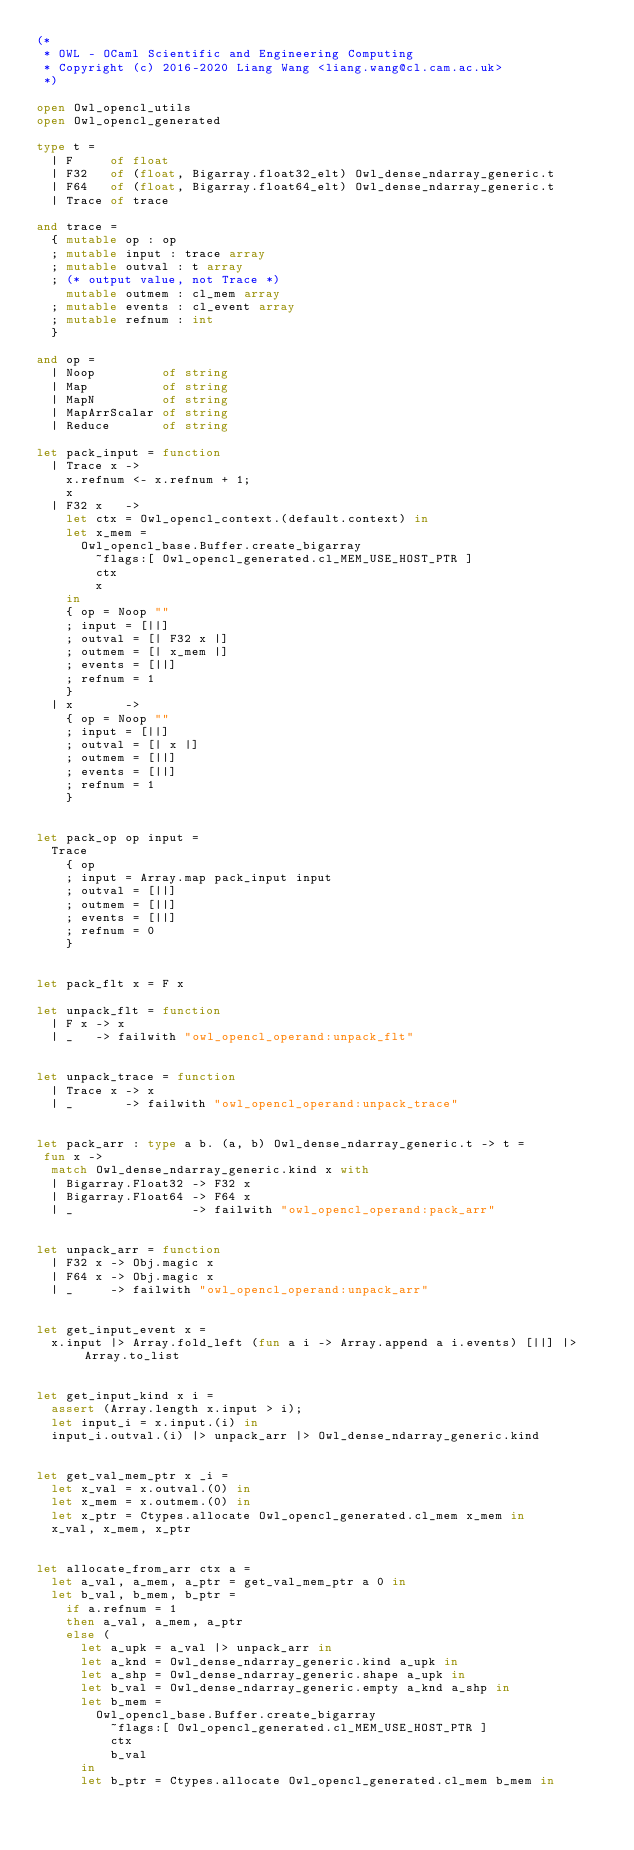<code> <loc_0><loc_0><loc_500><loc_500><_OCaml_>(*
 * OWL - OCaml Scientific and Engineering Computing
 * Copyright (c) 2016-2020 Liang Wang <liang.wang@cl.cam.ac.uk>
 *)

open Owl_opencl_utils
open Owl_opencl_generated

type t =
  | F     of float
  | F32   of (float, Bigarray.float32_elt) Owl_dense_ndarray_generic.t
  | F64   of (float, Bigarray.float64_elt) Owl_dense_ndarray_generic.t
  | Trace of trace

and trace =
  { mutable op : op
  ; mutable input : trace array
  ; mutable outval : t array
  ; (* output value, not Trace *)
    mutable outmem : cl_mem array
  ; mutable events : cl_event array
  ; mutable refnum : int
  }

and op =
  | Noop         of string
  | Map          of string
  | MapN         of string
  | MapArrScalar of string
  | Reduce       of string

let pack_input = function
  | Trace x ->
    x.refnum <- x.refnum + 1;
    x
  | F32 x   ->
    let ctx = Owl_opencl_context.(default.context) in
    let x_mem =
      Owl_opencl_base.Buffer.create_bigarray
        ~flags:[ Owl_opencl_generated.cl_MEM_USE_HOST_PTR ]
        ctx
        x
    in
    { op = Noop ""
    ; input = [||]
    ; outval = [| F32 x |]
    ; outmem = [| x_mem |]
    ; events = [||]
    ; refnum = 1
    }
  | x       ->
    { op = Noop ""
    ; input = [||]
    ; outval = [| x |]
    ; outmem = [||]
    ; events = [||]
    ; refnum = 1
    }


let pack_op op input =
  Trace
    { op
    ; input = Array.map pack_input input
    ; outval = [||]
    ; outmem = [||]
    ; events = [||]
    ; refnum = 0
    }


let pack_flt x = F x

let unpack_flt = function
  | F x -> x
  | _   -> failwith "owl_opencl_operand:unpack_flt"


let unpack_trace = function
  | Trace x -> x
  | _       -> failwith "owl_opencl_operand:unpack_trace"


let pack_arr : type a b. (a, b) Owl_dense_ndarray_generic.t -> t =
 fun x ->
  match Owl_dense_ndarray_generic.kind x with
  | Bigarray.Float32 -> F32 x
  | Bigarray.Float64 -> F64 x
  | _                -> failwith "owl_opencl_operand:pack_arr"


let unpack_arr = function
  | F32 x -> Obj.magic x
  | F64 x -> Obj.magic x
  | _     -> failwith "owl_opencl_operand:unpack_arr"


let get_input_event x =
  x.input |> Array.fold_left (fun a i -> Array.append a i.events) [||] |> Array.to_list


let get_input_kind x i =
  assert (Array.length x.input > i);
  let input_i = x.input.(i) in
  input_i.outval.(i) |> unpack_arr |> Owl_dense_ndarray_generic.kind


let get_val_mem_ptr x _i =
  let x_val = x.outval.(0) in
  let x_mem = x.outmem.(0) in
  let x_ptr = Ctypes.allocate Owl_opencl_generated.cl_mem x_mem in
  x_val, x_mem, x_ptr


let allocate_from_arr ctx a =
  let a_val, a_mem, a_ptr = get_val_mem_ptr a 0 in
  let b_val, b_mem, b_ptr =
    if a.refnum = 1
    then a_val, a_mem, a_ptr
    else (
      let a_upk = a_val |> unpack_arr in
      let a_knd = Owl_dense_ndarray_generic.kind a_upk in
      let a_shp = Owl_dense_ndarray_generic.shape a_upk in
      let b_val = Owl_dense_ndarray_generic.empty a_knd a_shp in
      let b_mem =
        Owl_opencl_base.Buffer.create_bigarray
          ~flags:[ Owl_opencl_generated.cl_MEM_USE_HOST_PTR ]
          ctx
          b_val
      in
      let b_ptr = Ctypes.allocate Owl_opencl_generated.cl_mem b_mem in</code> 